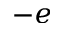<formula> <loc_0><loc_0><loc_500><loc_500>- e</formula> 